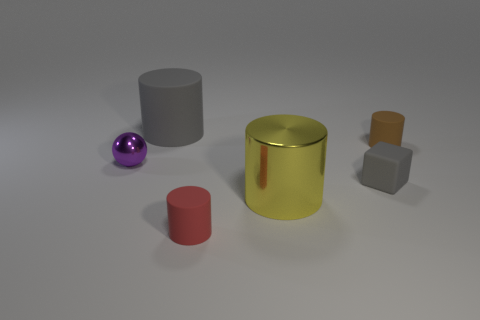Can you tell me the colors of the objects starting from the left? From the left, the first object is a purple sphere, followed by a gray cylinder. The large central object is a metallic gold cylinder, next is a red cylinder, and finally, a small orange cube is on the right. 